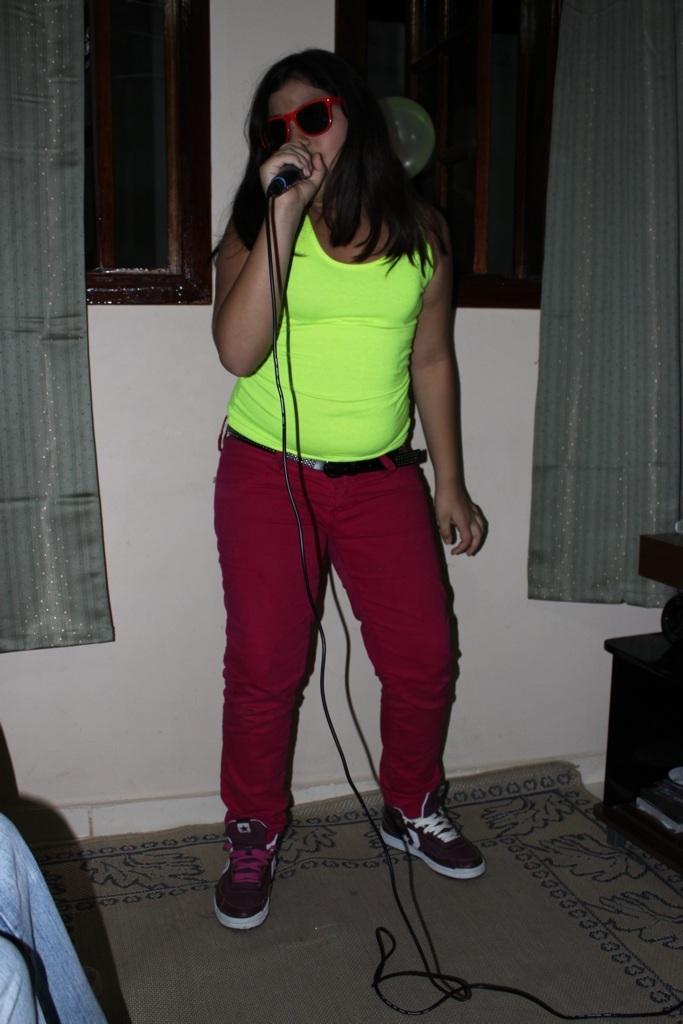How would you summarize this image in a sentence or two? There is a woman in light green color t-shirt, holding a mic, singing and standing on the floor. Which is covered with a carpet. On the right side, there is a person sitting on a chair. In the background, there are two curtains on the windows. And there is white wall. 